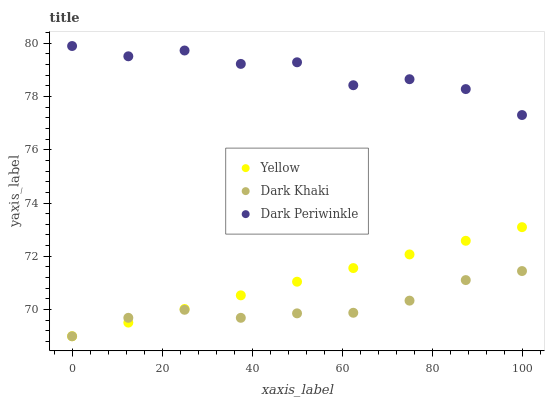Does Dark Khaki have the minimum area under the curve?
Answer yes or no. Yes. Does Dark Periwinkle have the maximum area under the curve?
Answer yes or no. Yes. Does Yellow have the minimum area under the curve?
Answer yes or no. No. Does Yellow have the maximum area under the curve?
Answer yes or no. No. Is Yellow the smoothest?
Answer yes or no. Yes. Is Dark Periwinkle the roughest?
Answer yes or no. Yes. Is Dark Periwinkle the smoothest?
Answer yes or no. No. Is Yellow the roughest?
Answer yes or no. No. Does Dark Khaki have the lowest value?
Answer yes or no. Yes. Does Dark Periwinkle have the lowest value?
Answer yes or no. No. Does Dark Periwinkle have the highest value?
Answer yes or no. Yes. Does Yellow have the highest value?
Answer yes or no. No. Is Dark Khaki less than Dark Periwinkle?
Answer yes or no. Yes. Is Dark Periwinkle greater than Dark Khaki?
Answer yes or no. Yes. Does Yellow intersect Dark Khaki?
Answer yes or no. Yes. Is Yellow less than Dark Khaki?
Answer yes or no. No. Is Yellow greater than Dark Khaki?
Answer yes or no. No. Does Dark Khaki intersect Dark Periwinkle?
Answer yes or no. No. 